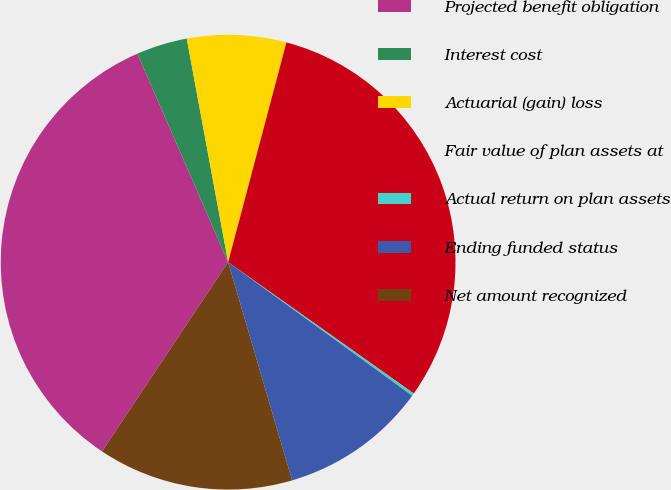Convert chart. <chart><loc_0><loc_0><loc_500><loc_500><pie_chart><fcel>Projected benefit obligation<fcel>Interest cost<fcel>Actuarial (gain) loss<fcel>Fair value of plan assets at<fcel>Actual return on plan assets<fcel>Ending funded status<fcel>Net amount recognized<nl><fcel>34.11%<fcel>3.62%<fcel>7.04%<fcel>30.67%<fcel>0.19%<fcel>10.47%<fcel>13.89%<nl></chart> 